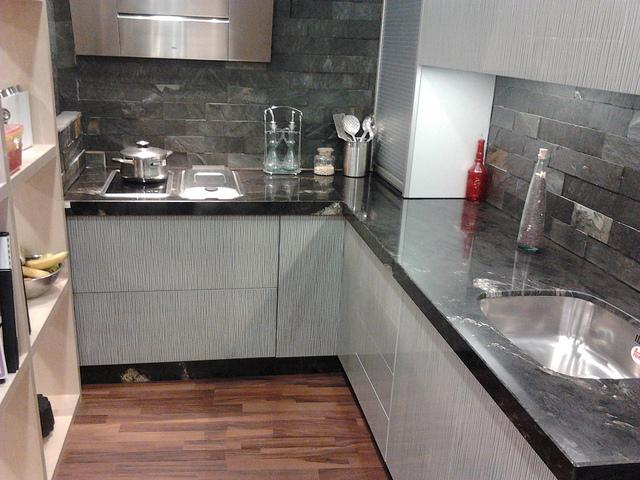What fruit is in the fruit bowl?
Answer briefly. Bananas. What color is predominant in the kitchen?
Keep it brief. Gray. The pot on the stove does it have a lid?
Answer briefly. Yes. 